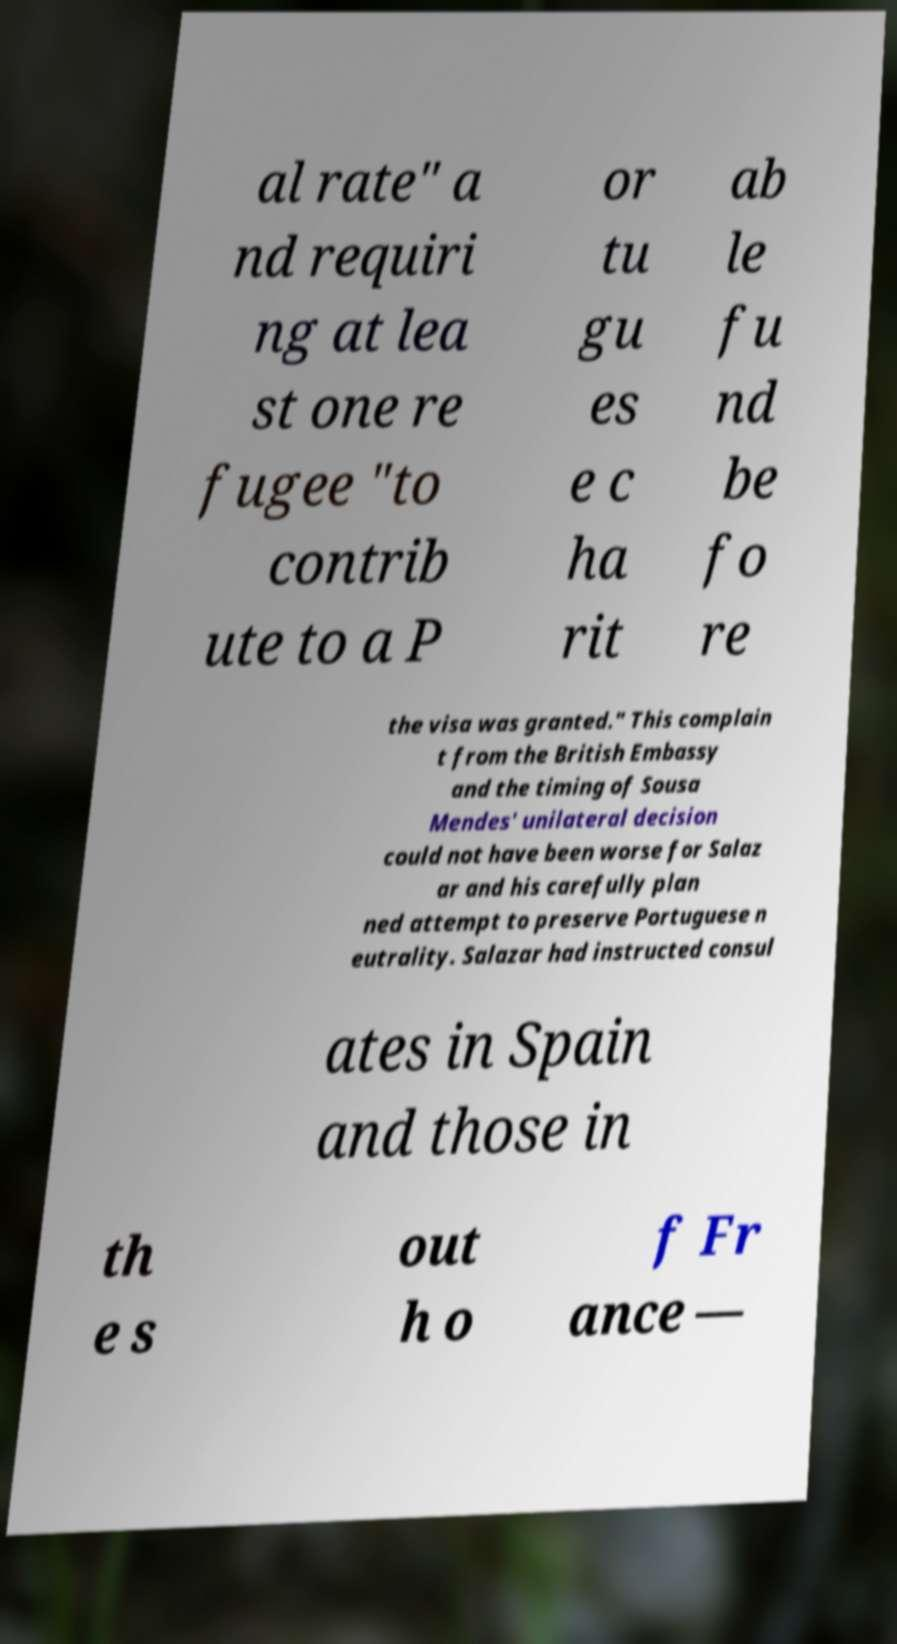Could you assist in decoding the text presented in this image and type it out clearly? al rate" a nd requiri ng at lea st one re fugee "to contrib ute to a P or tu gu es e c ha rit ab le fu nd be fo re the visa was granted." This complain t from the British Embassy and the timing of Sousa Mendes' unilateral decision could not have been worse for Salaz ar and his carefully plan ned attempt to preserve Portuguese n eutrality. Salazar had instructed consul ates in Spain and those in th e s out h o f Fr ance ― 